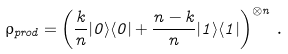<formula> <loc_0><loc_0><loc_500><loc_500>\rho _ { p r o d } = \left ( \frac { k } { n } | 0 \rangle \langle 0 | + \frac { n - k } { n } | 1 \rangle \langle 1 | \right ) ^ { \otimes n } \, .</formula> 